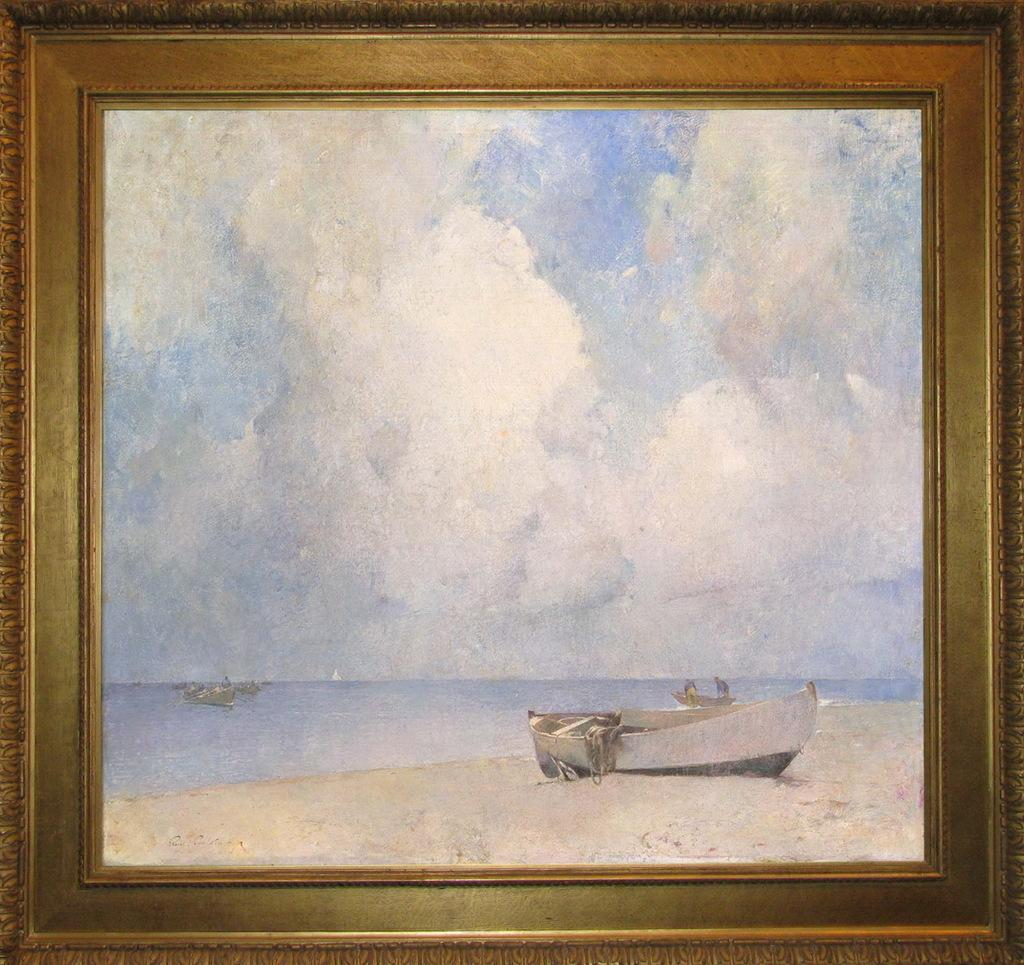What is the main subject of the image? The main subject of the image is a frame. What can be seen within the frame? Boats are sailing in the sea within the frame. Are there any boats outside the frame? Yes, there is a boat on the seashore. What is visible in the background of the image? The sky is visible in the background of the image. How many servants are attending to the boat on the seashore in the image? There is no mention of servants in the image; it only shows boats sailing in the sea and a boat on the seashore. What type of beast can be seen interacting with the boats in the image? There are no beasts present in the image; it only features boats sailing in the sea and a boat on the seashore. 